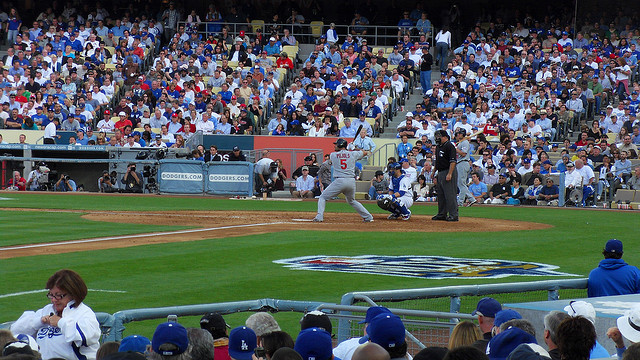Identify and read out the text in this image. 5 BOBBINS.COM 